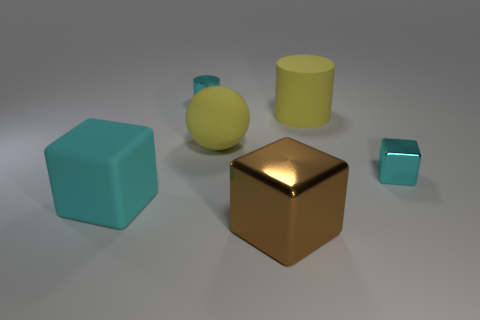Add 1 brown objects. How many objects exist? 7 Subtract all balls. How many objects are left? 5 Subtract all tiny brown matte cylinders. Subtract all big cyan matte things. How many objects are left? 5 Add 3 cyan objects. How many cyan objects are left? 6 Add 2 brown metal cylinders. How many brown metal cylinders exist? 2 Subtract 0 cyan spheres. How many objects are left? 6 